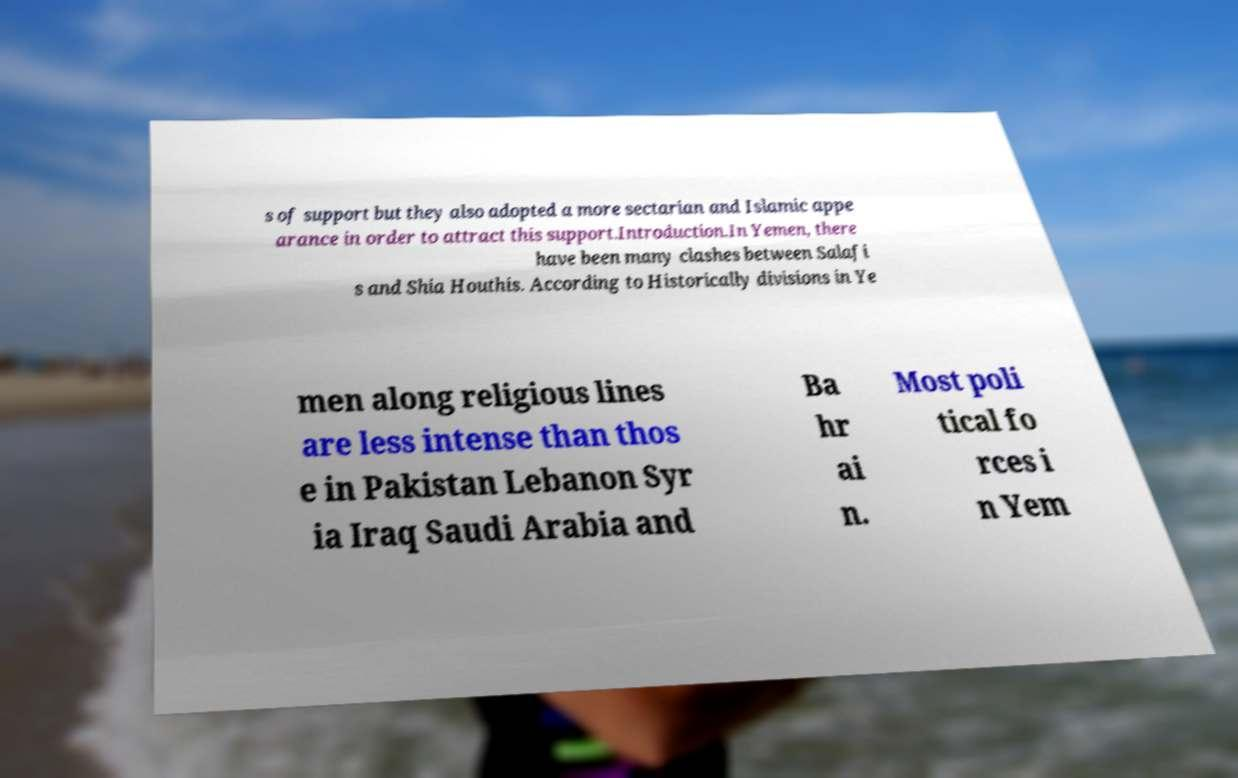Can you accurately transcribe the text from the provided image for me? s of support but they also adopted a more sectarian and Islamic appe arance in order to attract this support.Introduction.In Yemen, there have been many clashes between Salafi s and Shia Houthis. According to Historically divisions in Ye men along religious lines are less intense than thos e in Pakistan Lebanon Syr ia Iraq Saudi Arabia and Ba hr ai n. Most poli tical fo rces i n Yem 